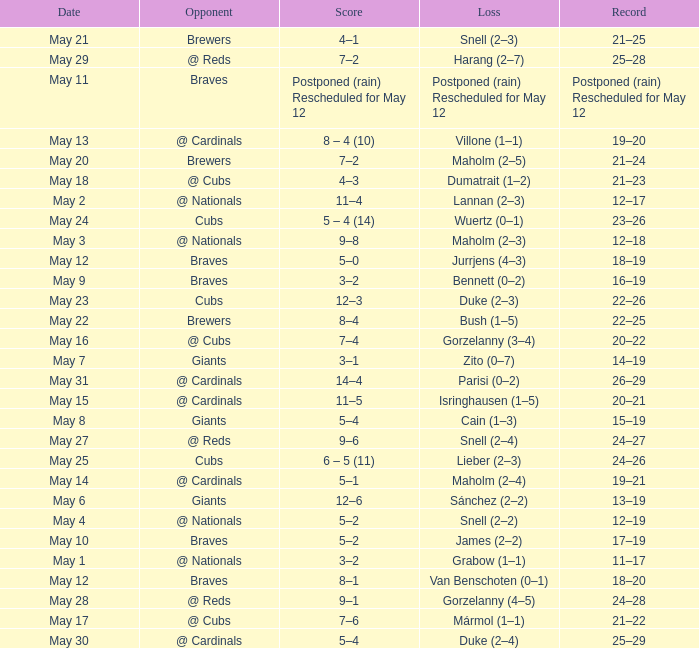Who was the opponent at the game with a score of 7–6? @ Cubs. 